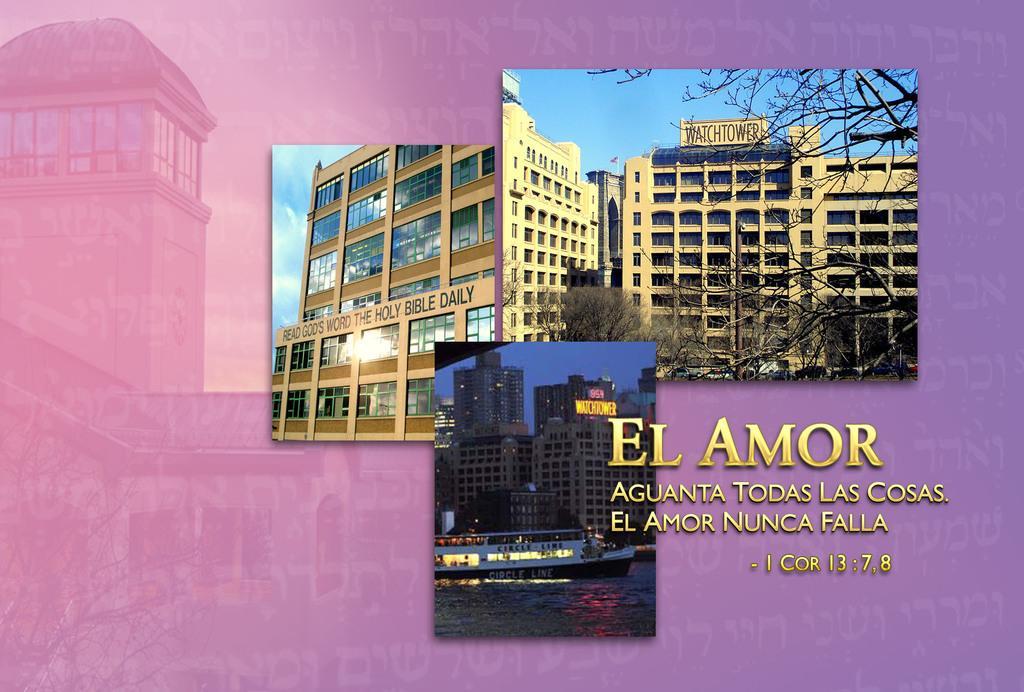How would you summarize this image in a sentence or two? This is an edited image. In this picture, we see the buildings and trees. We even see the water and a boat. We see the boards with some text written. On the right side, we see some text written. In the background, it is in violet or purple color. 